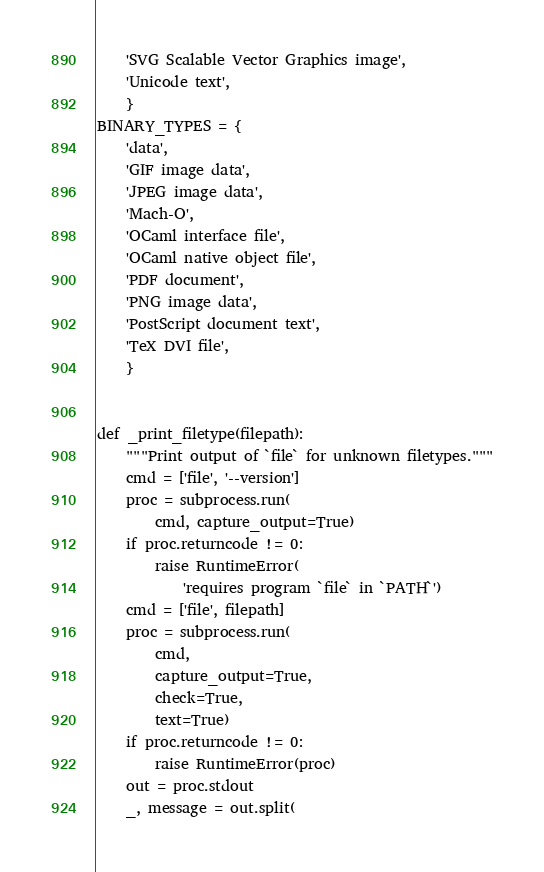<code> <loc_0><loc_0><loc_500><loc_500><_Python_>    'SVG Scalable Vector Graphics image',
    'Unicode text',
    }
BINARY_TYPES = {
    'data',
    'GIF image data',
    'JPEG image data',
    'Mach-O',
    'OCaml interface file',
    'OCaml native object file',
    'PDF document',
    'PNG image data',
    'PostScript document text',
    'TeX DVI file',
    }


def _print_filetype(filepath):
    """Print output of `file` for unknown filetypes."""
    cmd = ['file', '--version']
    proc = subprocess.run(
        cmd, capture_output=True)
    if proc.returncode != 0:
        raise RuntimeError(
            'requires program `file` in `PATH`')
    cmd = ['file', filepath]
    proc = subprocess.run(
        cmd,
        capture_output=True,
        check=True,
        text=True)
    if proc.returncode != 0:
        raise RuntimeError(proc)
    out = proc.stdout
    _, message = out.split(</code> 